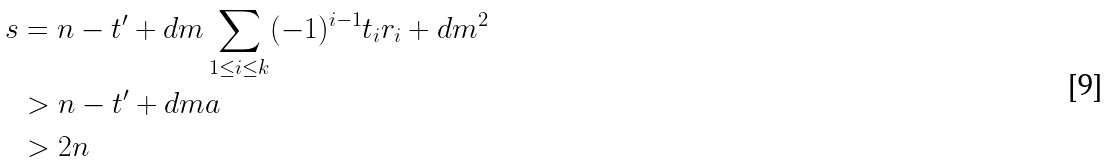<formula> <loc_0><loc_0><loc_500><loc_500>s & = n - t ^ { \prime } + d m \sum _ { 1 \leq i \leq k } ( - 1 ) ^ { i - 1 } t _ { i } r _ { i } + d m ^ { 2 } \\ & > n - t ^ { \prime } + d m a \\ & > 2 n</formula> 